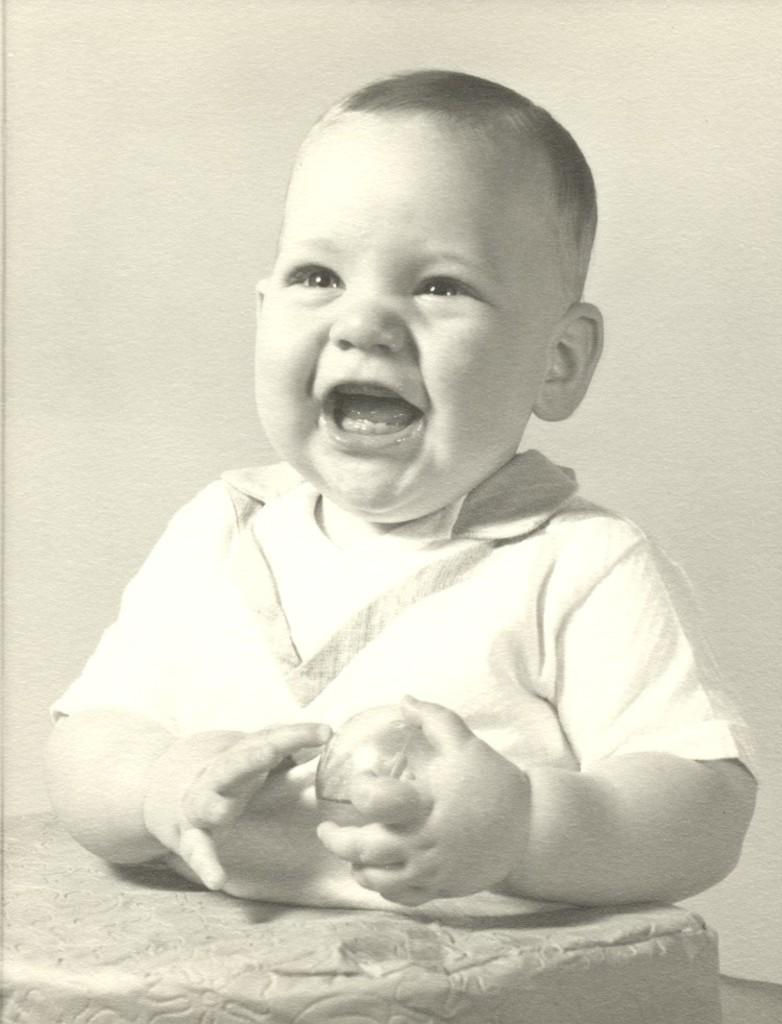What is the main subject of the image? There is a baby in the image. What is the baby doing in the image? The baby is holding an object. What type of bone can be seen in the image? There is no bone present in the image; it features a baby holding an object. 